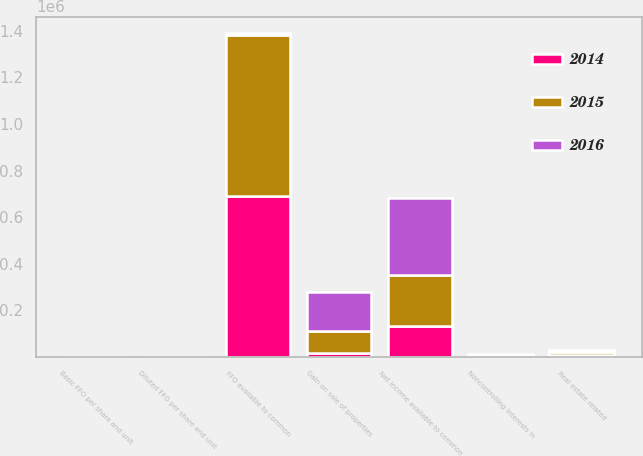Convert chart. <chart><loc_0><loc_0><loc_500><loc_500><stacked_bar_chart><ecel><fcel>Net income available to common<fcel>Noncontrolling interests in<fcel>Real estate related<fcel>Gain on sale of properties<fcel>FFO available to common<fcel>Basic FFO per share and unit<fcel>Diluted FFO per share and unit<nl><fcel>2016<fcel>332088<fcel>5298<fcel>11246<fcel>169902<fcel>11418<fcel>5.69<fcel>5.67<nl><fcel>2015<fcel>217266<fcel>4442<fcel>11418<fcel>94604<fcel>687896<fcel>4.88<fcel>4.86<nl><fcel>2014<fcel>132718<fcel>2767<fcel>7537<fcel>15945<fcel>691966<fcel>5.08<fcel>5.04<nl></chart> 